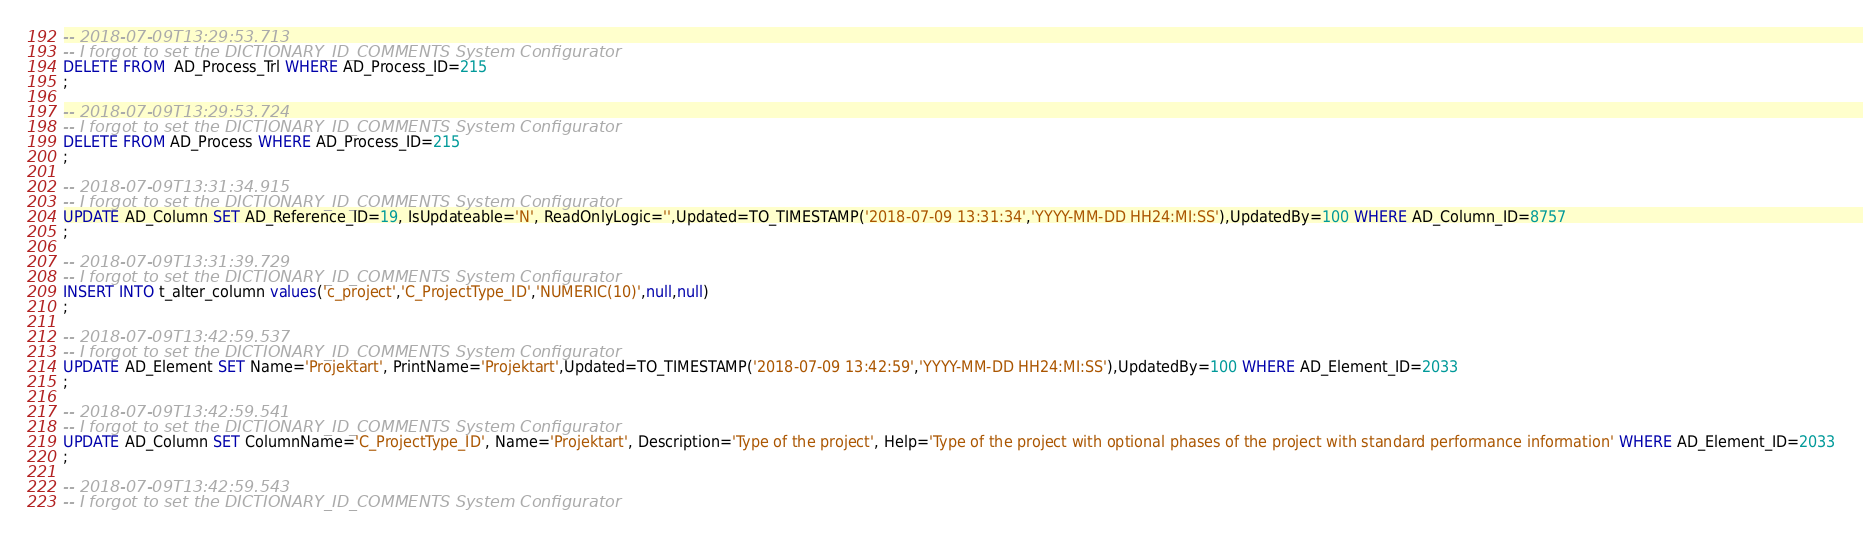Convert code to text. <code><loc_0><loc_0><loc_500><loc_500><_SQL_>-- 2018-07-09T13:29:53.713
-- I forgot to set the DICTIONARY_ID_COMMENTS System Configurator
DELETE FROM  AD_Process_Trl WHERE AD_Process_ID=215
;

-- 2018-07-09T13:29:53.724
-- I forgot to set the DICTIONARY_ID_COMMENTS System Configurator
DELETE FROM AD_Process WHERE AD_Process_ID=215
;

-- 2018-07-09T13:31:34.915
-- I forgot to set the DICTIONARY_ID_COMMENTS System Configurator
UPDATE AD_Column SET AD_Reference_ID=19, IsUpdateable='N', ReadOnlyLogic='',Updated=TO_TIMESTAMP('2018-07-09 13:31:34','YYYY-MM-DD HH24:MI:SS'),UpdatedBy=100 WHERE AD_Column_ID=8757
;

-- 2018-07-09T13:31:39.729
-- I forgot to set the DICTIONARY_ID_COMMENTS System Configurator
INSERT INTO t_alter_column values('c_project','C_ProjectType_ID','NUMERIC(10)',null,null)
;

-- 2018-07-09T13:42:59.537
-- I forgot to set the DICTIONARY_ID_COMMENTS System Configurator
UPDATE AD_Element SET Name='Projektart', PrintName='Projektart',Updated=TO_TIMESTAMP('2018-07-09 13:42:59','YYYY-MM-DD HH24:MI:SS'),UpdatedBy=100 WHERE AD_Element_ID=2033
;

-- 2018-07-09T13:42:59.541
-- I forgot to set the DICTIONARY_ID_COMMENTS System Configurator
UPDATE AD_Column SET ColumnName='C_ProjectType_ID', Name='Projektart', Description='Type of the project', Help='Type of the project with optional phases of the project with standard performance information' WHERE AD_Element_ID=2033
;

-- 2018-07-09T13:42:59.543
-- I forgot to set the DICTIONARY_ID_COMMENTS System Configurator</code> 